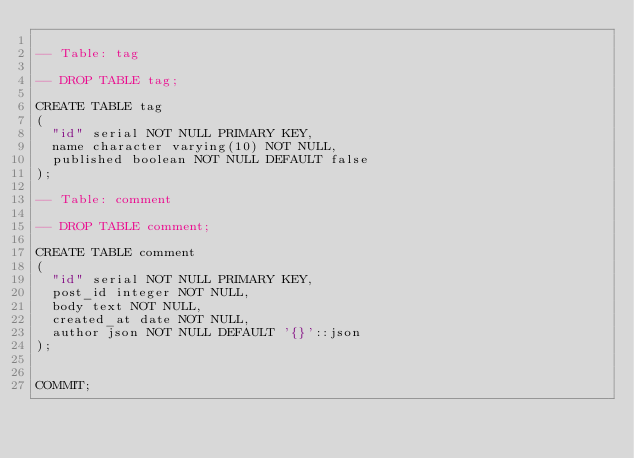<code> <loc_0><loc_0><loc_500><loc_500><_SQL_>
-- Table: tag

-- DROP TABLE tag;

CREATE TABLE tag
(
  "id" serial NOT NULL PRIMARY KEY,
  name character varying(10) NOT NULL,
  published boolean NOT NULL DEFAULT false
);

-- Table: comment

-- DROP TABLE comment;

CREATE TABLE comment
(
  "id" serial NOT NULL PRIMARY KEY,
  post_id integer NOT NULL,
  body text NOT NULL,
  created_at date NOT NULL,
  author json NOT NULL DEFAULT '{}'::json
);


COMMIT;
</code> 